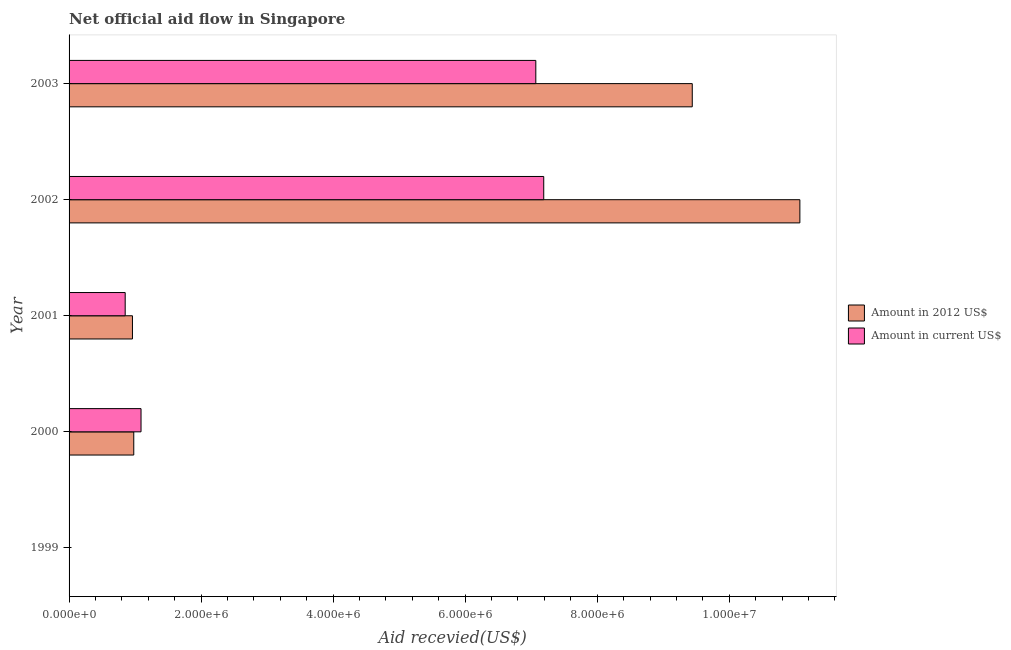How many different coloured bars are there?
Make the answer very short. 2. How many bars are there on the 5th tick from the top?
Your answer should be very brief. 0. What is the amount of aid received(expressed in 2012 us$) in 2000?
Offer a terse response. 9.80e+05. Across all years, what is the maximum amount of aid received(expressed in 2012 us$)?
Keep it short and to the point. 1.11e+07. What is the total amount of aid received(expressed in 2012 us$) in the graph?
Offer a terse response. 2.24e+07. What is the difference between the amount of aid received(expressed in us$) in 2000 and that in 2003?
Your answer should be compact. -5.98e+06. What is the difference between the amount of aid received(expressed in 2012 us$) in 1999 and the amount of aid received(expressed in us$) in 2002?
Your answer should be very brief. -7.19e+06. What is the average amount of aid received(expressed in 2012 us$) per year?
Offer a very short reply. 4.49e+06. In the year 2002, what is the difference between the amount of aid received(expressed in 2012 us$) and amount of aid received(expressed in us$)?
Keep it short and to the point. 3.88e+06. In how many years, is the amount of aid received(expressed in us$) greater than 2800000 US$?
Provide a succinct answer. 2. What is the ratio of the amount of aid received(expressed in us$) in 2001 to that in 2003?
Keep it short and to the point. 0.12. Is the difference between the amount of aid received(expressed in us$) in 2001 and 2003 greater than the difference between the amount of aid received(expressed in 2012 us$) in 2001 and 2003?
Ensure brevity in your answer.  Yes. What is the difference between the highest and the second highest amount of aid received(expressed in 2012 us$)?
Give a very brief answer. 1.63e+06. What is the difference between the highest and the lowest amount of aid received(expressed in us$)?
Your response must be concise. 7.19e+06. How many bars are there?
Ensure brevity in your answer.  8. What is the difference between two consecutive major ticks on the X-axis?
Your answer should be compact. 2.00e+06. Are the values on the major ticks of X-axis written in scientific E-notation?
Make the answer very short. Yes. Does the graph contain any zero values?
Offer a terse response. Yes. Does the graph contain grids?
Your answer should be compact. No. How are the legend labels stacked?
Keep it short and to the point. Vertical. What is the title of the graph?
Your answer should be very brief. Net official aid flow in Singapore. Does "Formally registered" appear as one of the legend labels in the graph?
Offer a very short reply. No. What is the label or title of the X-axis?
Give a very brief answer. Aid recevied(US$). What is the Aid recevied(US$) of Amount in current US$ in 1999?
Ensure brevity in your answer.  0. What is the Aid recevied(US$) of Amount in 2012 US$ in 2000?
Your answer should be compact. 9.80e+05. What is the Aid recevied(US$) in Amount in current US$ in 2000?
Give a very brief answer. 1.09e+06. What is the Aid recevied(US$) of Amount in 2012 US$ in 2001?
Keep it short and to the point. 9.60e+05. What is the Aid recevied(US$) in Amount in current US$ in 2001?
Give a very brief answer. 8.50e+05. What is the Aid recevied(US$) of Amount in 2012 US$ in 2002?
Your answer should be very brief. 1.11e+07. What is the Aid recevied(US$) in Amount in current US$ in 2002?
Your answer should be very brief. 7.19e+06. What is the Aid recevied(US$) in Amount in 2012 US$ in 2003?
Your answer should be very brief. 9.44e+06. What is the Aid recevied(US$) in Amount in current US$ in 2003?
Give a very brief answer. 7.07e+06. Across all years, what is the maximum Aid recevied(US$) of Amount in 2012 US$?
Provide a succinct answer. 1.11e+07. Across all years, what is the maximum Aid recevied(US$) of Amount in current US$?
Give a very brief answer. 7.19e+06. Across all years, what is the minimum Aid recevied(US$) of Amount in current US$?
Keep it short and to the point. 0. What is the total Aid recevied(US$) of Amount in 2012 US$ in the graph?
Your response must be concise. 2.24e+07. What is the total Aid recevied(US$) in Amount in current US$ in the graph?
Your answer should be very brief. 1.62e+07. What is the difference between the Aid recevied(US$) in Amount in 2012 US$ in 2000 and that in 2001?
Provide a succinct answer. 2.00e+04. What is the difference between the Aid recevied(US$) of Amount in 2012 US$ in 2000 and that in 2002?
Provide a succinct answer. -1.01e+07. What is the difference between the Aid recevied(US$) in Amount in current US$ in 2000 and that in 2002?
Provide a short and direct response. -6.10e+06. What is the difference between the Aid recevied(US$) of Amount in 2012 US$ in 2000 and that in 2003?
Give a very brief answer. -8.46e+06. What is the difference between the Aid recevied(US$) of Amount in current US$ in 2000 and that in 2003?
Make the answer very short. -5.98e+06. What is the difference between the Aid recevied(US$) in Amount in 2012 US$ in 2001 and that in 2002?
Make the answer very short. -1.01e+07. What is the difference between the Aid recevied(US$) of Amount in current US$ in 2001 and that in 2002?
Offer a terse response. -6.34e+06. What is the difference between the Aid recevied(US$) in Amount in 2012 US$ in 2001 and that in 2003?
Ensure brevity in your answer.  -8.48e+06. What is the difference between the Aid recevied(US$) of Amount in current US$ in 2001 and that in 2003?
Your response must be concise. -6.22e+06. What is the difference between the Aid recevied(US$) of Amount in 2012 US$ in 2002 and that in 2003?
Make the answer very short. 1.63e+06. What is the difference between the Aid recevied(US$) in Amount in 2012 US$ in 2000 and the Aid recevied(US$) in Amount in current US$ in 2002?
Keep it short and to the point. -6.21e+06. What is the difference between the Aid recevied(US$) of Amount in 2012 US$ in 2000 and the Aid recevied(US$) of Amount in current US$ in 2003?
Your response must be concise. -6.09e+06. What is the difference between the Aid recevied(US$) of Amount in 2012 US$ in 2001 and the Aid recevied(US$) of Amount in current US$ in 2002?
Provide a succinct answer. -6.23e+06. What is the difference between the Aid recevied(US$) of Amount in 2012 US$ in 2001 and the Aid recevied(US$) of Amount in current US$ in 2003?
Your answer should be very brief. -6.11e+06. What is the average Aid recevied(US$) of Amount in 2012 US$ per year?
Ensure brevity in your answer.  4.49e+06. What is the average Aid recevied(US$) of Amount in current US$ per year?
Ensure brevity in your answer.  3.24e+06. In the year 2002, what is the difference between the Aid recevied(US$) in Amount in 2012 US$ and Aid recevied(US$) in Amount in current US$?
Offer a terse response. 3.88e+06. In the year 2003, what is the difference between the Aid recevied(US$) in Amount in 2012 US$ and Aid recevied(US$) in Amount in current US$?
Offer a very short reply. 2.37e+06. What is the ratio of the Aid recevied(US$) in Amount in 2012 US$ in 2000 to that in 2001?
Your answer should be very brief. 1.02. What is the ratio of the Aid recevied(US$) in Amount in current US$ in 2000 to that in 2001?
Offer a very short reply. 1.28. What is the ratio of the Aid recevied(US$) of Amount in 2012 US$ in 2000 to that in 2002?
Provide a short and direct response. 0.09. What is the ratio of the Aid recevied(US$) in Amount in current US$ in 2000 to that in 2002?
Keep it short and to the point. 0.15. What is the ratio of the Aid recevied(US$) in Amount in 2012 US$ in 2000 to that in 2003?
Ensure brevity in your answer.  0.1. What is the ratio of the Aid recevied(US$) of Amount in current US$ in 2000 to that in 2003?
Your response must be concise. 0.15. What is the ratio of the Aid recevied(US$) of Amount in 2012 US$ in 2001 to that in 2002?
Your answer should be compact. 0.09. What is the ratio of the Aid recevied(US$) in Amount in current US$ in 2001 to that in 2002?
Your response must be concise. 0.12. What is the ratio of the Aid recevied(US$) of Amount in 2012 US$ in 2001 to that in 2003?
Keep it short and to the point. 0.1. What is the ratio of the Aid recevied(US$) in Amount in current US$ in 2001 to that in 2003?
Ensure brevity in your answer.  0.12. What is the ratio of the Aid recevied(US$) in Amount in 2012 US$ in 2002 to that in 2003?
Keep it short and to the point. 1.17. What is the ratio of the Aid recevied(US$) of Amount in current US$ in 2002 to that in 2003?
Your answer should be very brief. 1.02. What is the difference between the highest and the second highest Aid recevied(US$) of Amount in 2012 US$?
Make the answer very short. 1.63e+06. What is the difference between the highest and the second highest Aid recevied(US$) in Amount in current US$?
Keep it short and to the point. 1.20e+05. What is the difference between the highest and the lowest Aid recevied(US$) in Amount in 2012 US$?
Your answer should be very brief. 1.11e+07. What is the difference between the highest and the lowest Aid recevied(US$) of Amount in current US$?
Make the answer very short. 7.19e+06. 